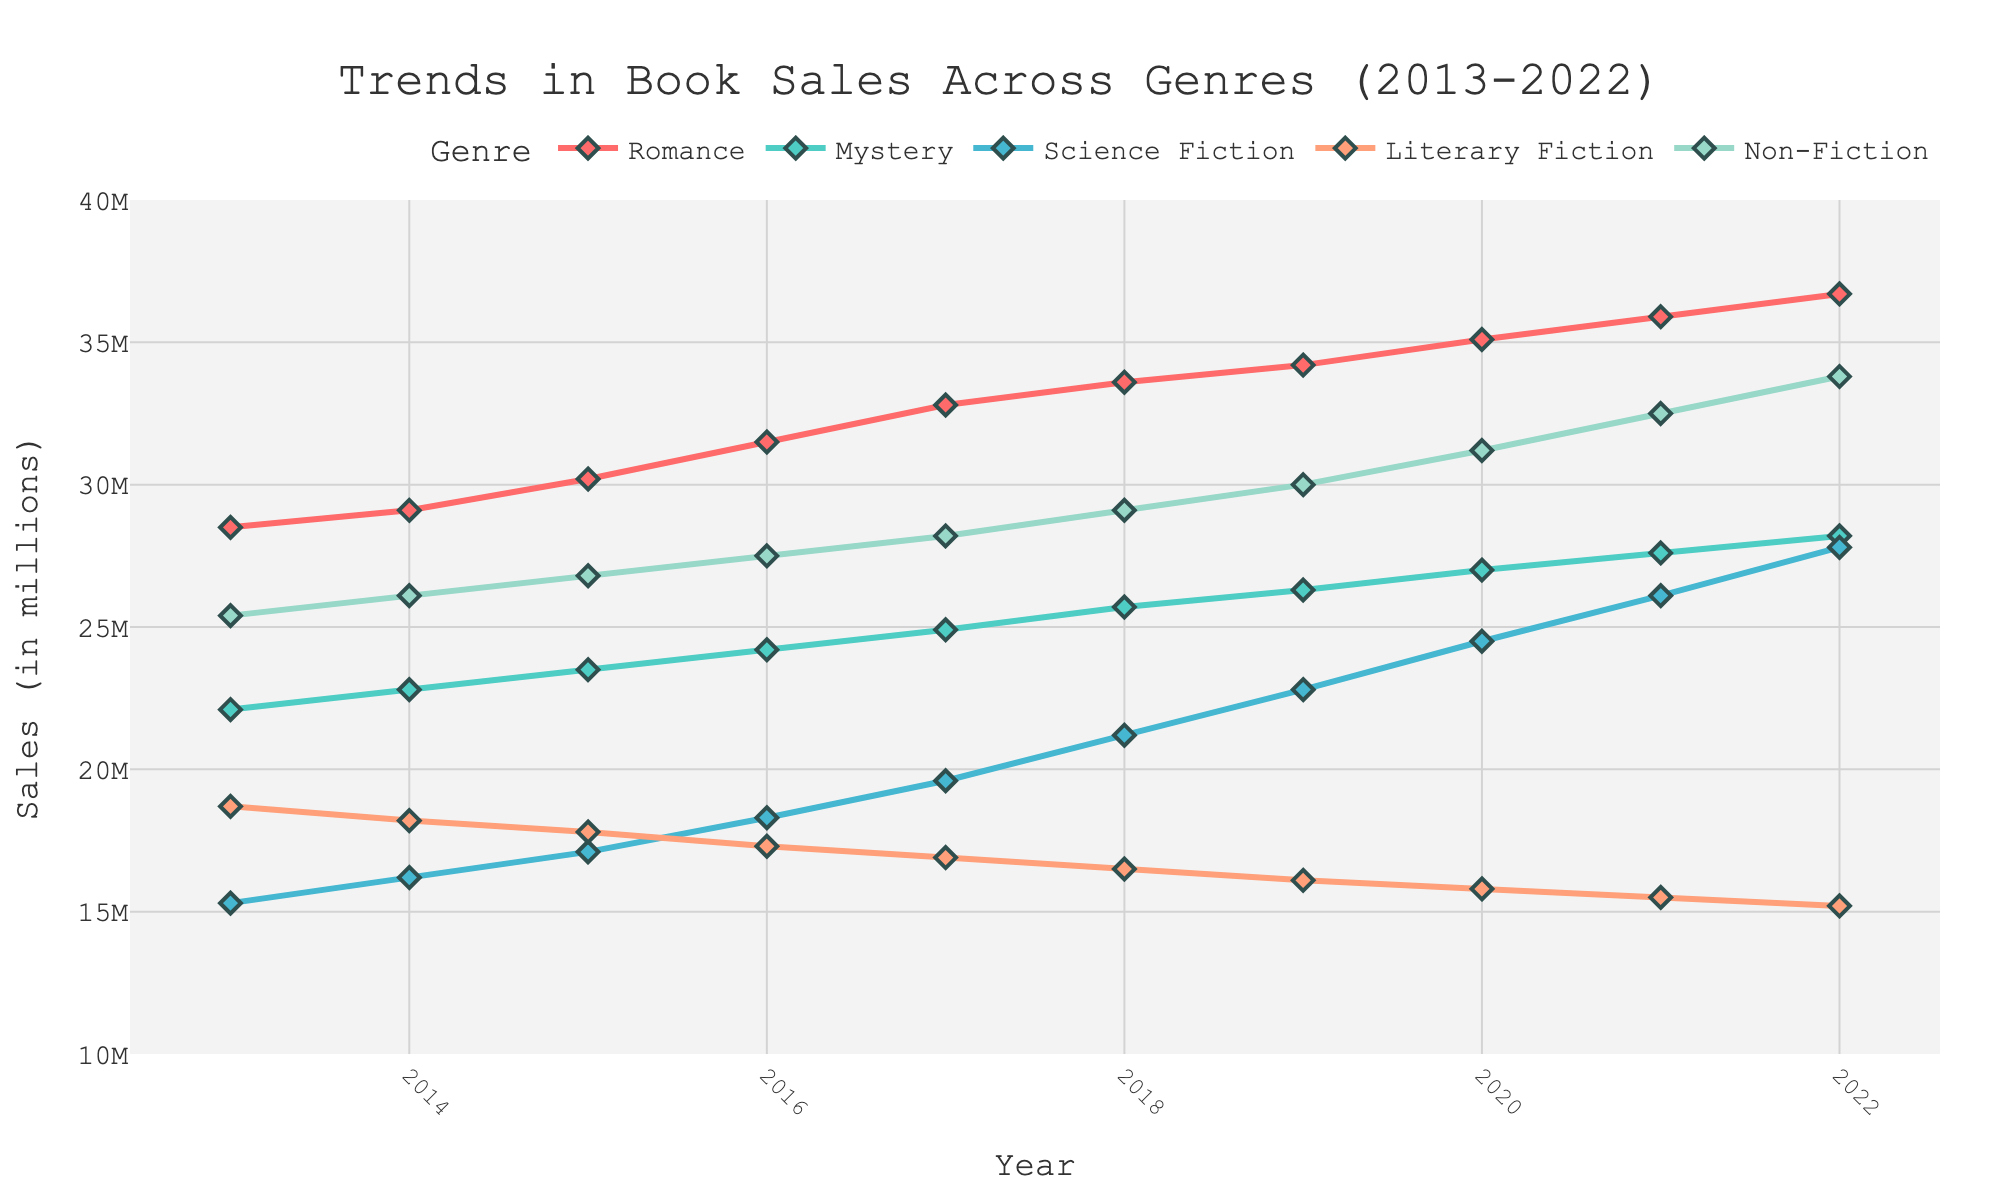What's the overall trend in Romance book sales from 2013 to 2022? To determine the trend, observe the line for Romance, which shows a continuous increase from 28.5 million in 2013 to 36.7 million in 2022.
Answer: Increasing Which genre had the greatest increase in sales over the decade? Calculate the difference in sales for each genre from 2013 to 2022 and compare. Romance increased by 36.7 - 28.5 = 8.2 million. Mystery increased by 28.2 - 22.1 = 6.1 million. Science Fiction increased by 27.8 - 15.3 = 12.5 million. Literary Fiction decreased. Non-Fiction increased by 33.8 - 25.4 = 8.4 million. Science Fiction has the greatest increase of 12.5 million.
Answer: Science Fiction In which year did Non-Fiction book sales surpass 30 million? Look for the first year where the Non-Fiction sales line is above 30 million. This occurs in 2019.
Answer: 2019 Compare the sales of Literary Fiction and Mystery books in 2022. Which one is higher, and by how much? From the figure, Literary Fiction sales in 2022 are 15.2 million, and Mystery sales are 28.2 million. Subtract Literary Fiction from Mystery: 28.2 - 15.2 = 13 million.
Answer: Mystery by 13 million What is the average annual sales growth for Science Fiction books from 2013 to 2022? To calculate the average annual growth: (final sales - initial sales) / number of years = (27.8 - 15.3) / (2022 - 2013) = 12.5 / 9 ≈ 1.39 million per year.
Answer: 1.39 million In which year did Romance book sales reach 35 million? Check the Romance sales data to find the first year it hits 35 million. It occurs in 2020.
Answer: 2020 How do Non-Fiction book sales in 2013 compare to Mystery book sales in 2022? Non-Fiction sales in 2013 were 25.4 million, and Mystery sales in 2022 were 28.2 million. Non-Fiction in 2013 is less than Mystery in 2022.
Answer: Less What is the difference in sales between the highest and lowest-selling genres in 2016? In 2016, Romance: 31.5, Mystery: 24.2, Science Fiction: 18.3, Literary Fiction: 17.3, Non-Fiction: 27.5. The highest is Non-Fiction (27.5) and the lowest is Literary Fiction (17.3). Difference: 27.5 - 17.3 = 10.2 million.
Answer: 10.2 million 